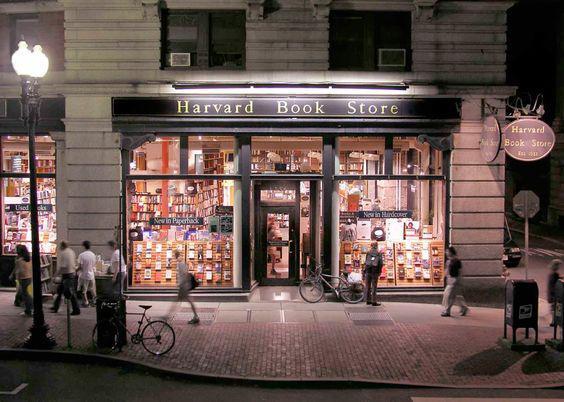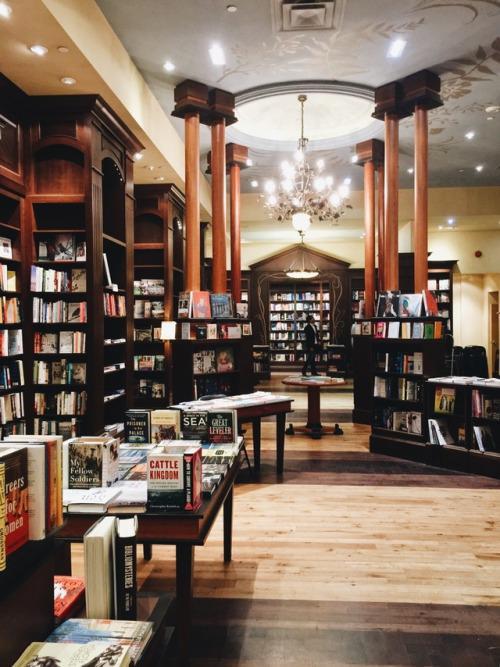The first image is the image on the left, the second image is the image on the right. Evaluate the accuracy of this statement regarding the images: "In at least one image there is a door and two window at the front of the bookstore.". Is it true? Answer yes or no. Yes. The first image is the image on the left, the second image is the image on the right. Examine the images to the left and right. Is the description "There are human beings visible in at least one image." accurate? Answer yes or no. Yes. 